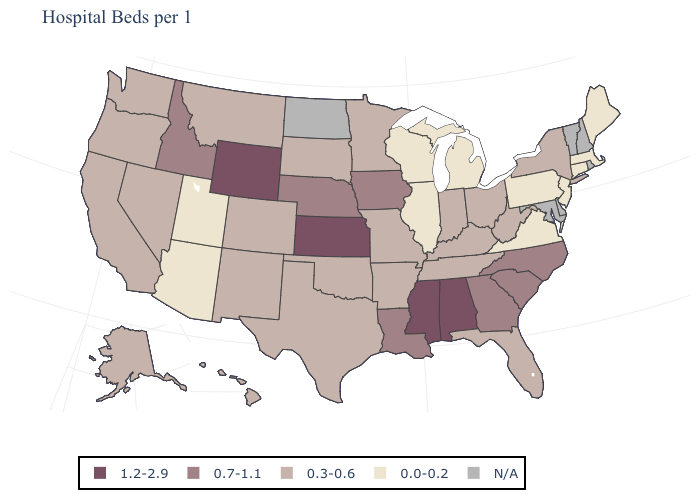Name the states that have a value in the range 0.0-0.2?
Concise answer only. Arizona, Connecticut, Illinois, Maine, Massachusetts, Michigan, New Jersey, Pennsylvania, Utah, Virginia, Wisconsin. What is the value of Wisconsin?
Answer briefly. 0.0-0.2. Among the states that border Maryland , which have the highest value?
Concise answer only. West Virginia. Name the states that have a value in the range N/A?
Short answer required. Delaware, Maryland, New Hampshire, North Dakota, Rhode Island, Vermont. Name the states that have a value in the range 0.3-0.6?
Quick response, please. Alaska, Arkansas, California, Colorado, Florida, Hawaii, Indiana, Kentucky, Minnesota, Missouri, Montana, Nevada, New Mexico, New York, Ohio, Oklahoma, Oregon, South Dakota, Tennessee, Texas, Washington, West Virginia. Does the first symbol in the legend represent the smallest category?
Keep it brief. No. What is the highest value in states that border New Jersey?
Be succinct. 0.3-0.6. What is the highest value in states that border Rhode Island?
Short answer required. 0.0-0.2. Name the states that have a value in the range 1.2-2.9?
Answer briefly. Alabama, Kansas, Mississippi, Wyoming. Among the states that border Wisconsin , which have the lowest value?
Give a very brief answer. Illinois, Michigan. Does the first symbol in the legend represent the smallest category?
Be succinct. No. What is the value of South Carolina?
Give a very brief answer. 0.7-1.1. Name the states that have a value in the range 0.0-0.2?
Short answer required. Arizona, Connecticut, Illinois, Maine, Massachusetts, Michigan, New Jersey, Pennsylvania, Utah, Virginia, Wisconsin. What is the lowest value in the USA?
Be succinct. 0.0-0.2. 